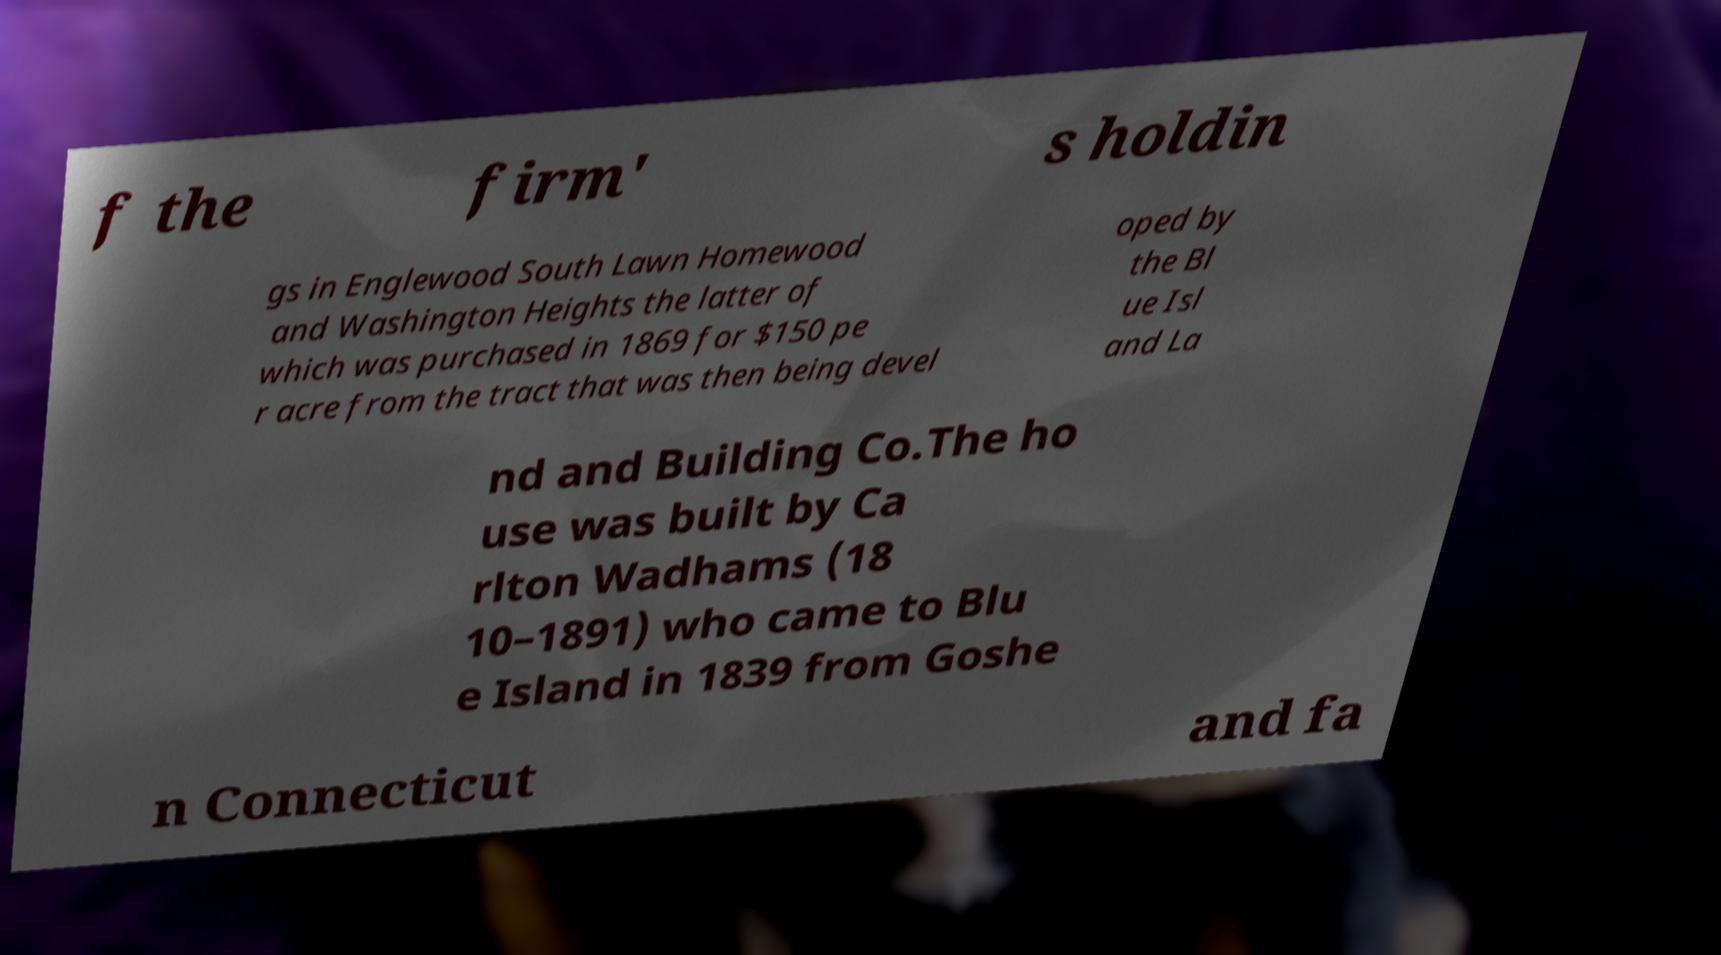Could you extract and type out the text from this image? f the firm' s holdin gs in Englewood South Lawn Homewood and Washington Heights the latter of which was purchased in 1869 for $150 pe r acre from the tract that was then being devel oped by the Bl ue Isl and La nd and Building Co.The ho use was built by Ca rlton Wadhams (18 10–1891) who came to Blu e Island in 1839 from Goshe n Connecticut and fa 